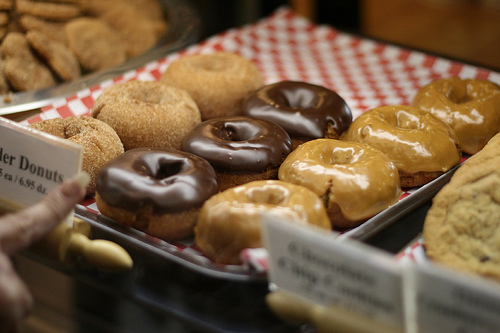Read and extract the text from this image. ter Donuts 